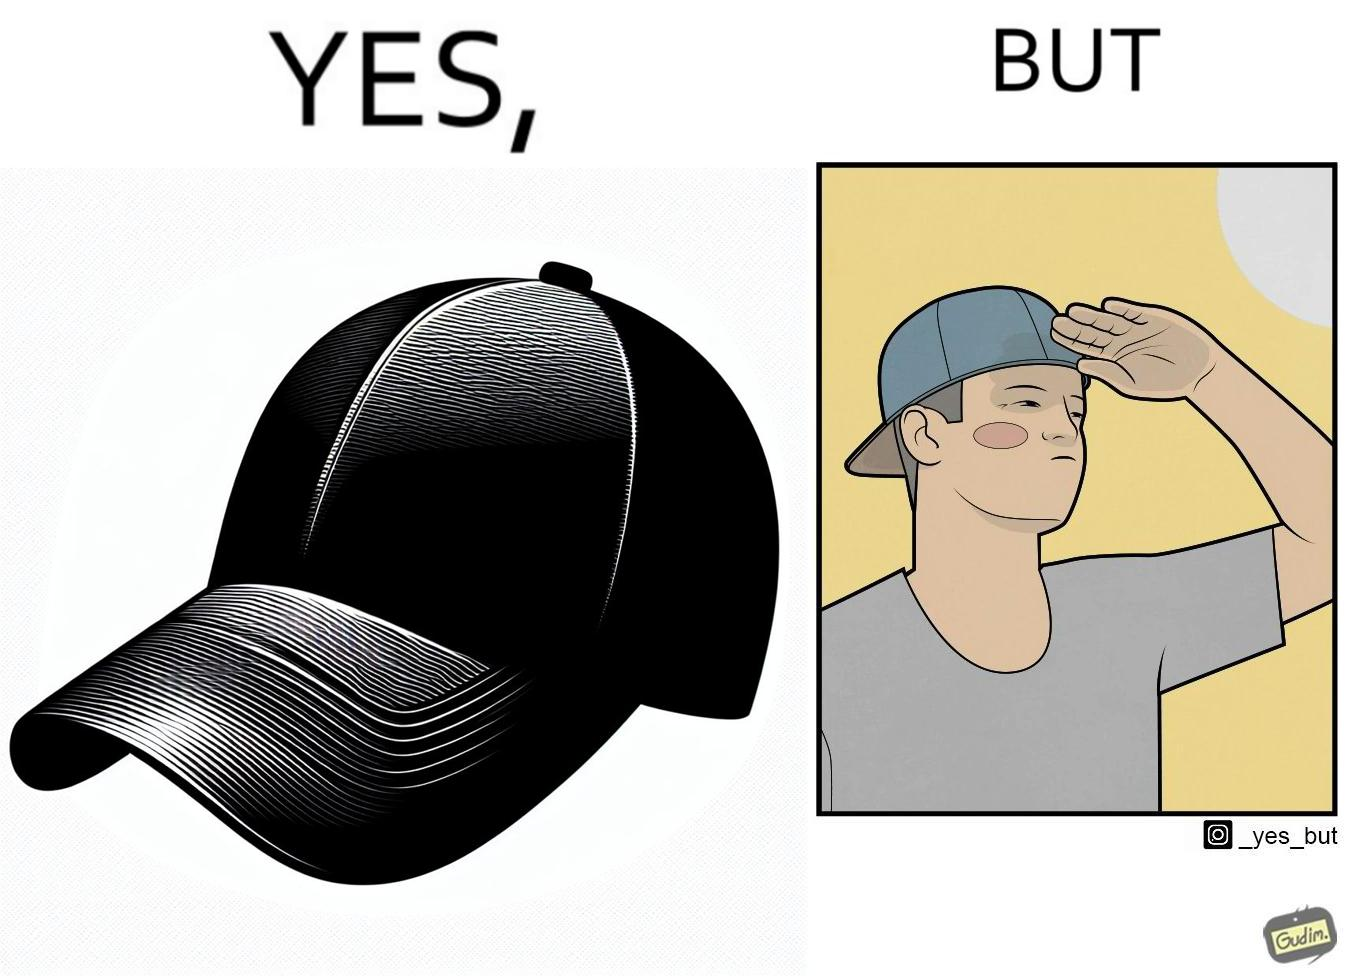Describe what you see in the left and right parts of this image. In the left part of the image: A regular ordinary cap that is meant to shield one's eyes from the sun In the right part of the image: A person wearing a cap backwards to look stylish. Sun is very brightly shining on their face, making them uncomfortable so they squint their eyes and use their hand to shadow their face from the sun. 